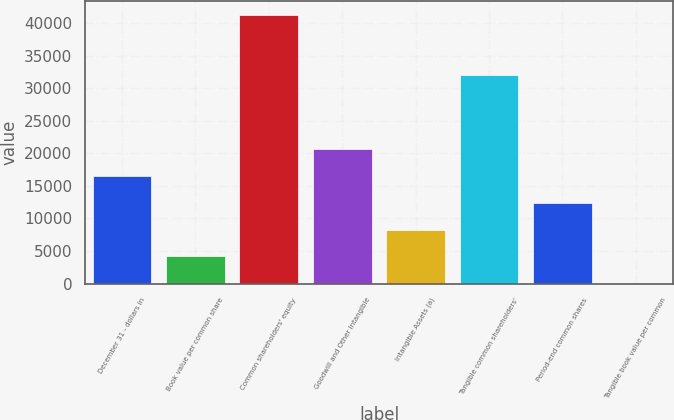<chart> <loc_0><loc_0><loc_500><loc_500><bar_chart><fcel>December 31 - dollars in<fcel>Book value per common share<fcel>Common shareholders' equity<fcel>Goodwill and Other Intangible<fcel>Intangible Assets (a)<fcel>Tangible common shareholders'<fcel>Period-end common shares<fcel>Tangible book value per common<nl><fcel>16541.4<fcel>4183.09<fcel>41258<fcel>20660.8<fcel>8302.53<fcel>32086<fcel>12422<fcel>63.65<nl></chart> 